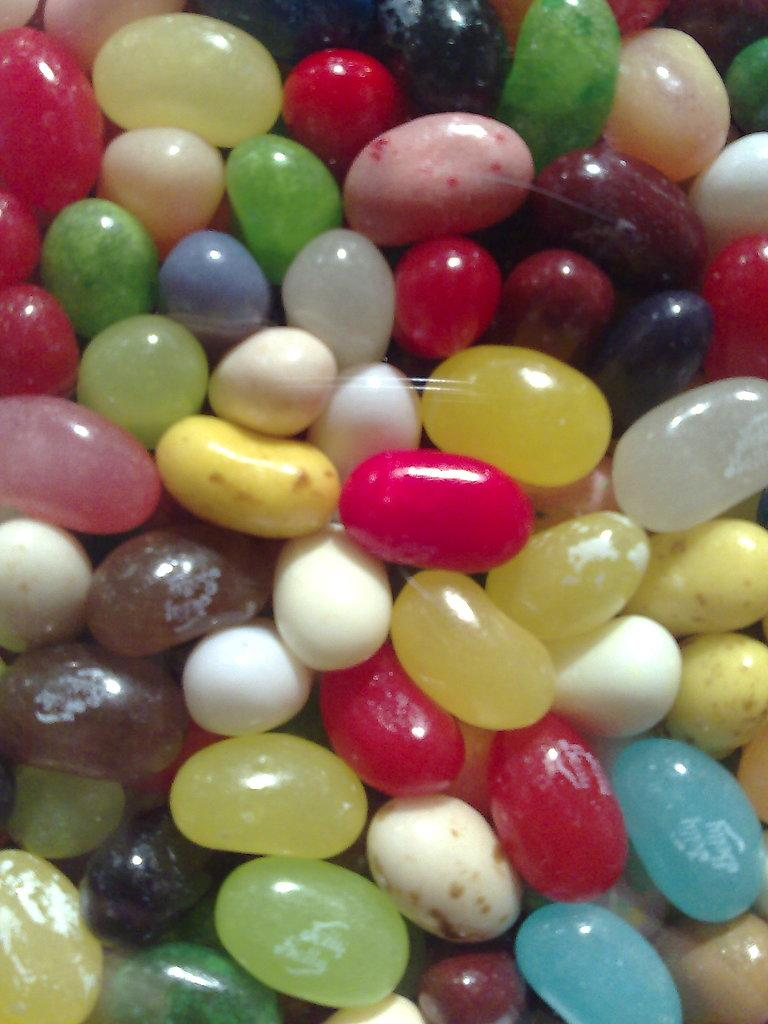What type of objects can be seen in the image? There are colorful candies in the image. Can you describe the appearance of the candies? The candies are colorful, which suggests they come in various shades and hues. What might be the purpose of these candies? The candies are likely meant for consumption, as they are often used as a sweet treat or snack. What type of plant is growing in the potato in the image? There is no plant or potato present in the image; it only features colorful candies. 